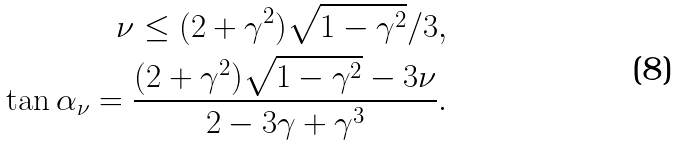Convert formula to latex. <formula><loc_0><loc_0><loc_500><loc_500>\nu \leq ( 2 + \gamma ^ { 2 } ) \sqrt { 1 - \gamma ^ { 2 } } / 3 , \\ \tan \alpha _ { \nu } = \frac { ( 2 + \gamma ^ { 2 } ) \sqrt { 1 - \gamma ^ { 2 } } - 3 \nu } { 2 - 3 \gamma + \gamma ^ { 3 } } .</formula> 